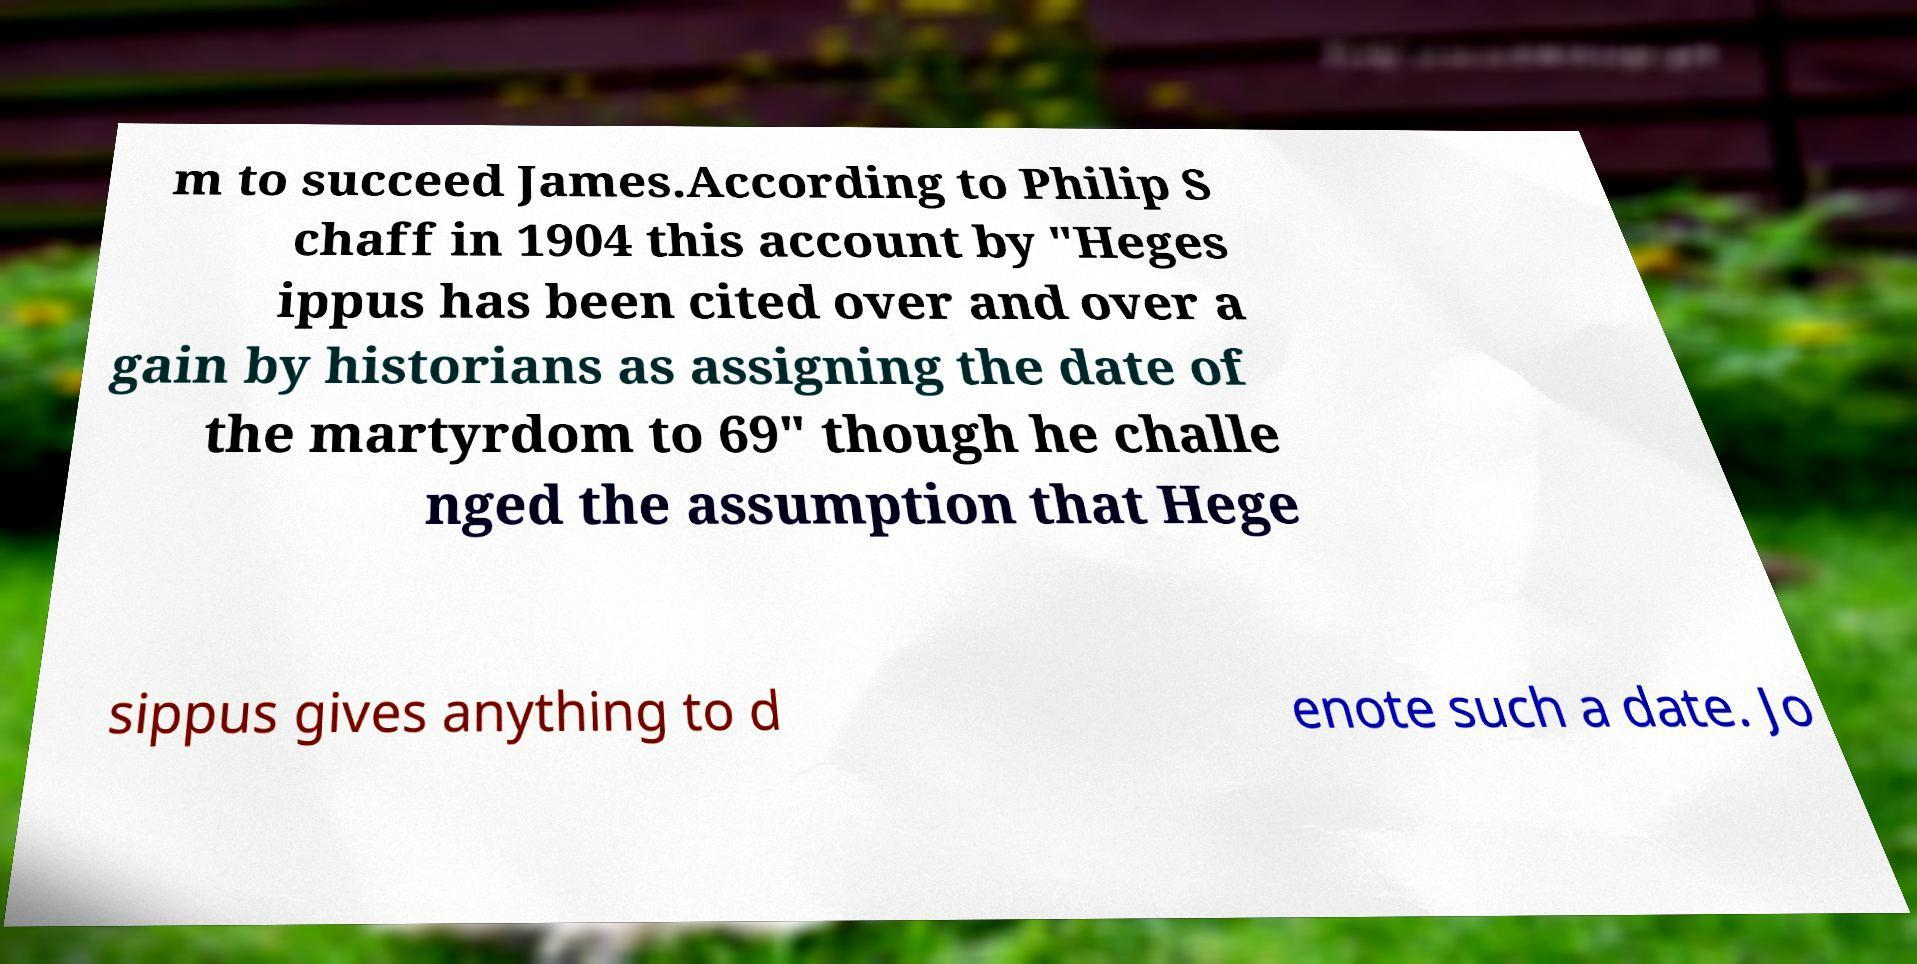Can you read and provide the text displayed in the image?This photo seems to have some interesting text. Can you extract and type it out for me? m to succeed James.According to Philip S chaff in 1904 this account by "Heges ippus has been cited over and over a gain by historians as assigning the date of the martyrdom to 69" though he challe nged the assumption that Hege sippus gives anything to d enote such a date. Jo 